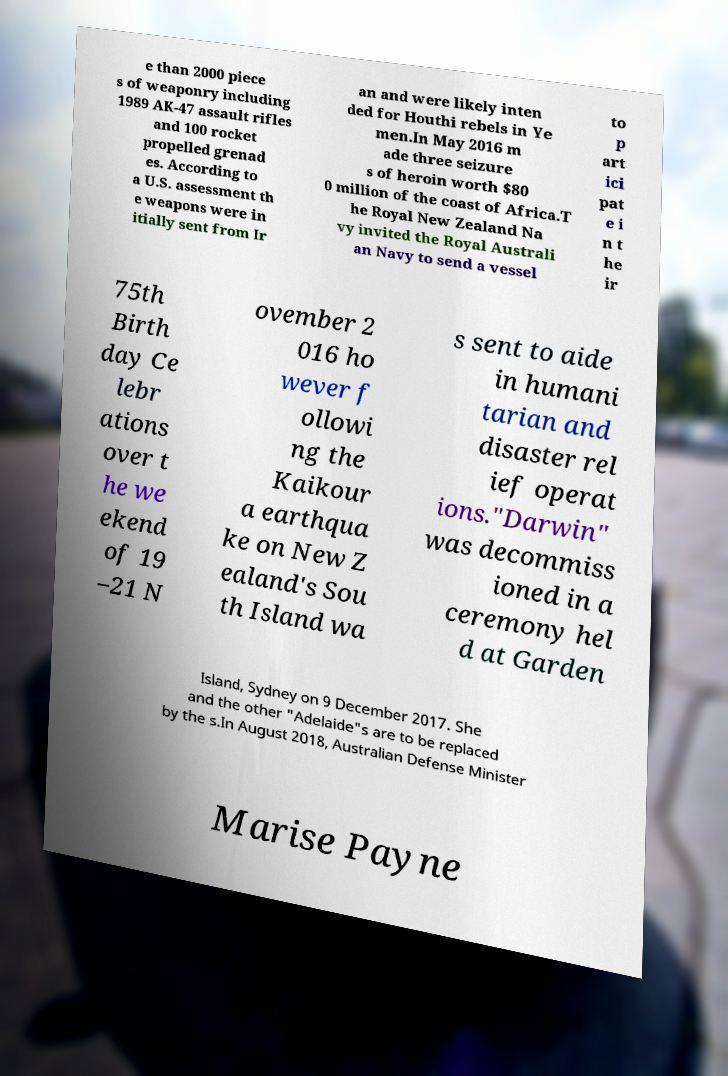I need the written content from this picture converted into text. Can you do that? e than 2000 piece s of weaponry including 1989 AK-47 assault rifles and 100 rocket propelled grenad es. According to a U.S. assessment th e weapons were in itially sent from Ir an and were likely inten ded for Houthi rebels in Ye men.In May 2016 m ade three seizure s of heroin worth $80 0 million of the coast of Africa.T he Royal New Zealand Na vy invited the Royal Australi an Navy to send a vessel to p art ici pat e i n t he ir 75th Birth day Ce lebr ations over t he we ekend of 19 –21 N ovember 2 016 ho wever f ollowi ng the Kaikour a earthqua ke on New Z ealand's Sou th Island wa s sent to aide in humani tarian and disaster rel ief operat ions."Darwin" was decommiss ioned in a ceremony hel d at Garden Island, Sydney on 9 December 2017. She and the other "Adelaide"s are to be replaced by the s.In August 2018, Australian Defense Minister Marise Payne 